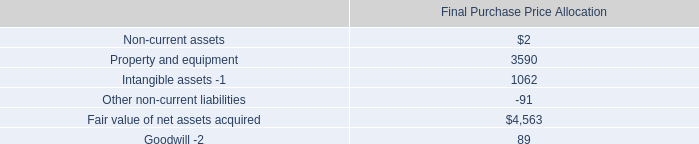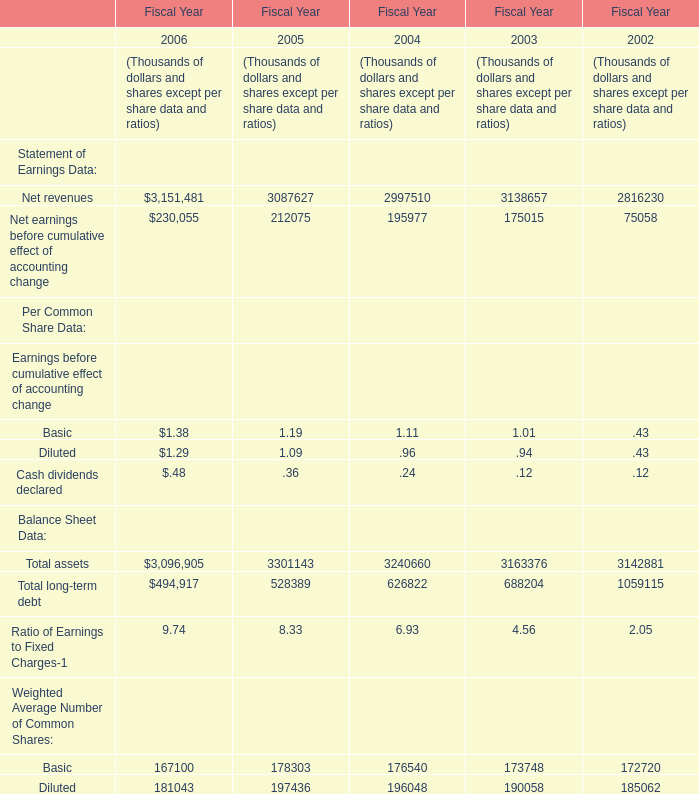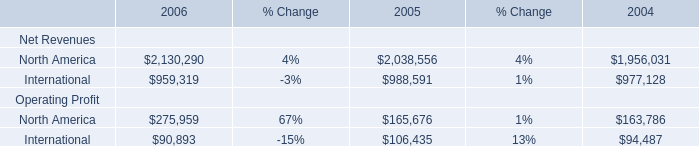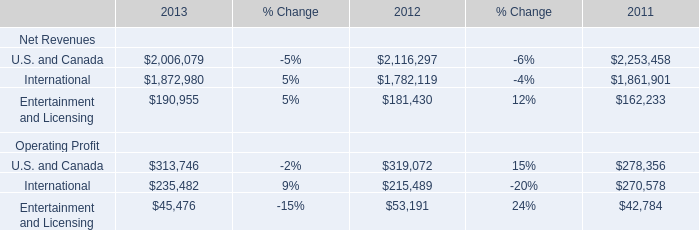What is the value of the Net revenues in the year where the Total long-term debt is greater than 1000000 thousand, in terms of Fiscal Year ? (in thousand) 
Answer: 2816230. 